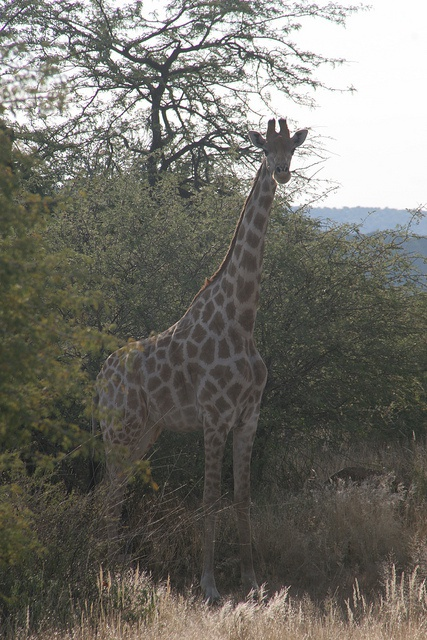Describe the objects in this image and their specific colors. I can see a giraffe in beige, gray, and black tones in this image. 